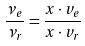<formula> <loc_0><loc_0><loc_500><loc_500>\frac { \nu _ { e } } { \nu _ { r } } = \frac { x \cdot v _ { e } } { x \cdot v _ { r } }</formula> 